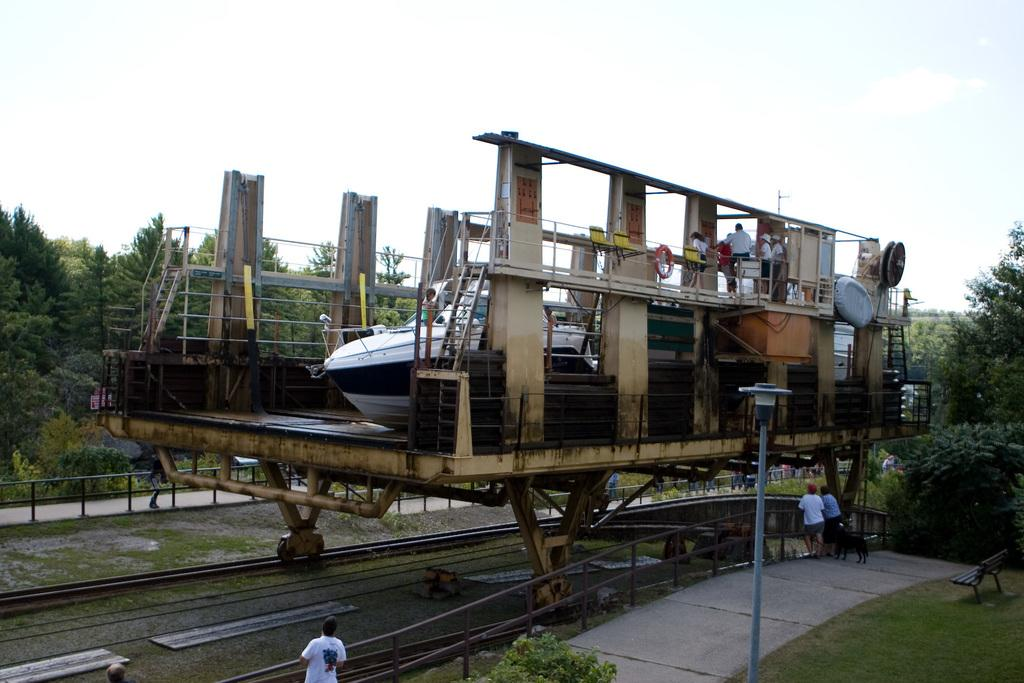What is the main subject of the image? The main subject of the image is a boat. What other objects or elements can be seen in the image? There are trees, a pole, a bench, and people visible in the image. What is the background of the image? The sky is visible in the background of the image, and clouds are present in the sky. How many people are in the image? There are people in the image, but the exact number is not specified. How do the boats shake hands with each other in the image? There are no boats shaking hands in the image, as there is only one boat visible. Can you describe the interaction between the friends in the image? There is no mention of friends or their interactions in the image. The image only shows a boat, trees, a pole, a bench, people, and the sky with clouds. 